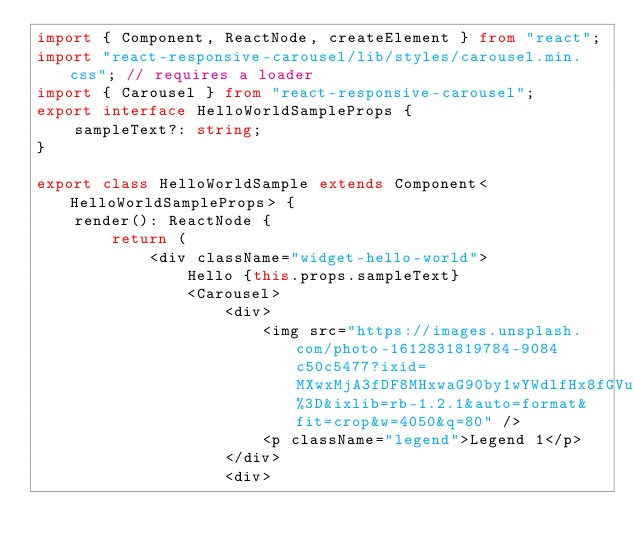<code> <loc_0><loc_0><loc_500><loc_500><_TypeScript_>import { Component, ReactNode, createElement } from "react";
import "react-responsive-carousel/lib/styles/carousel.min.css"; // requires a loader
import { Carousel } from "react-responsive-carousel";
export interface HelloWorldSampleProps {
    sampleText?: string;
}

export class HelloWorldSample extends Component<HelloWorldSampleProps> {
    render(): ReactNode {
        return (
            <div className="widget-hello-world">
                Hello {this.props.sampleText}
                <Carousel>
                    <div>
                        <img src="https://images.unsplash.com/photo-1612831819784-9084c50c5477?ixid=MXwxMjA3fDF8MHxwaG90by1wYWdlfHx8fGVufDB8fHw%3D&ixlib=rb-1.2.1&auto=format&fit=crop&w=4050&q=80" />
                        <p className="legend">Legend 1</p>
                    </div>
                    <div></code> 